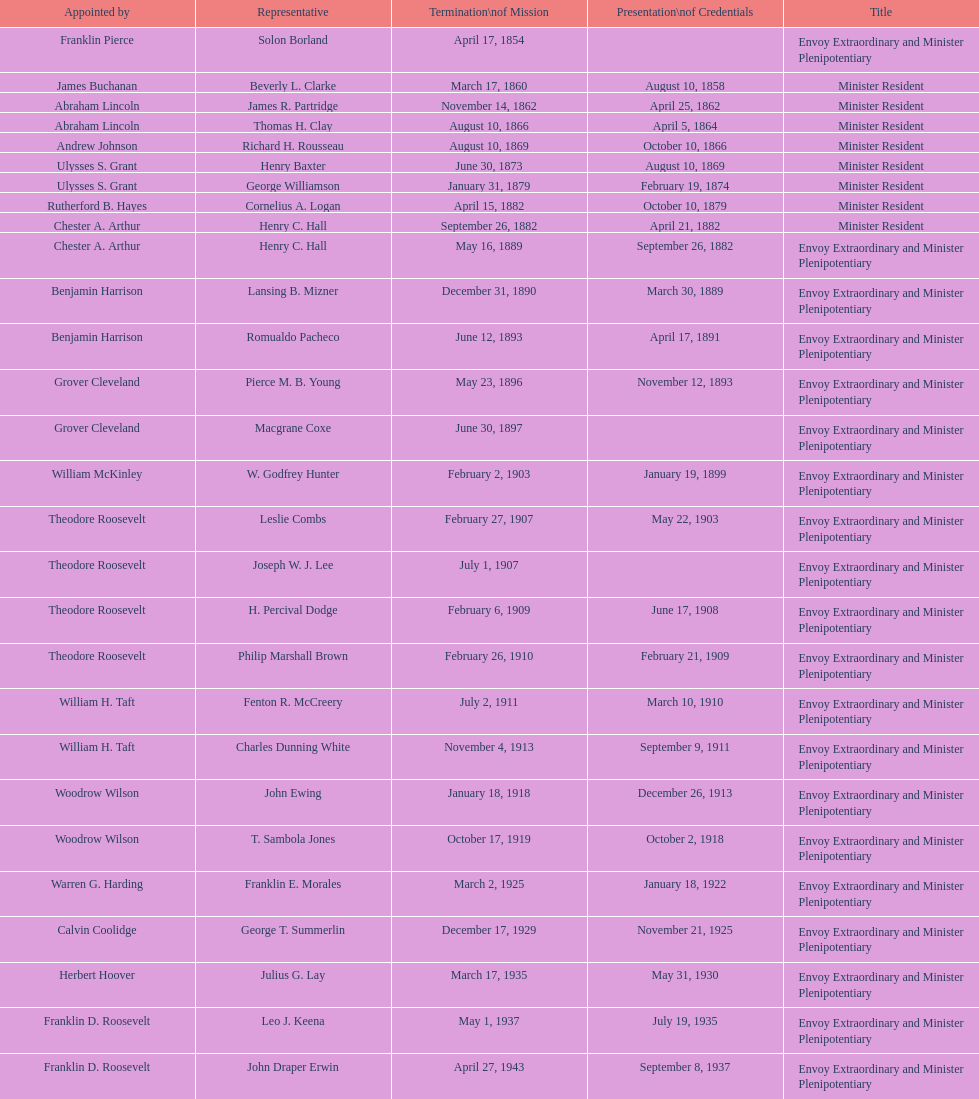Who is the only ambassadors to honduras appointed by barack obama? Lisa Kubiske. 